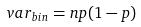<formula> <loc_0><loc_0><loc_500><loc_500>v a r _ { b i n } = n p ( 1 - p )</formula> 